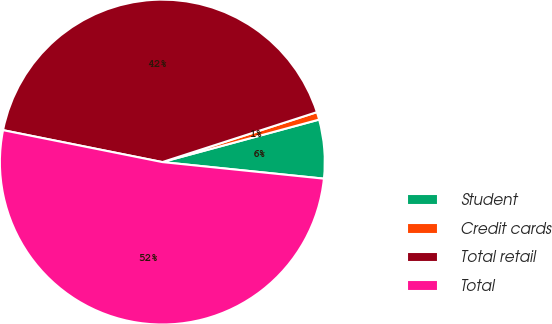Convert chart to OTSL. <chart><loc_0><loc_0><loc_500><loc_500><pie_chart><fcel>Student<fcel>Credit cards<fcel>Total retail<fcel>Total<nl><fcel>5.84%<fcel>0.76%<fcel>41.88%<fcel>51.52%<nl></chart> 